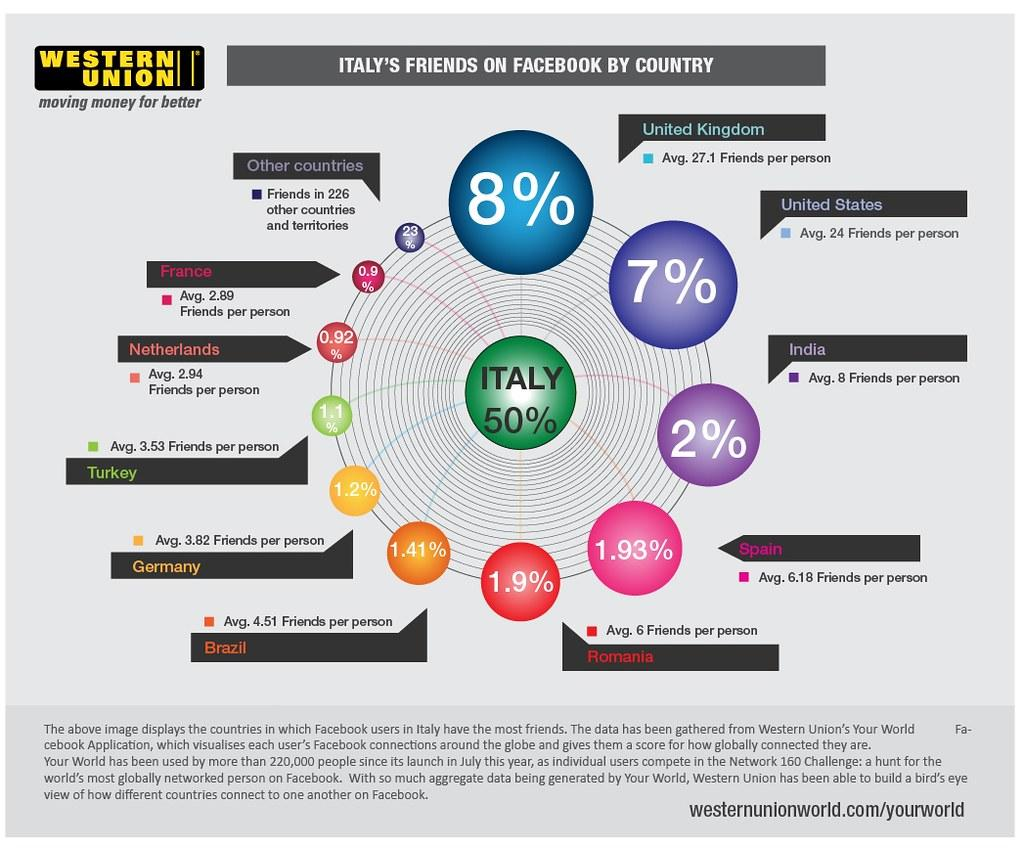Outline some significant characteristics in this image. The country with the lowest percentage of friends from Italy on Facebook is France. According to data, approximately 2% of Facebook friends in Italy are from India. Brazil has the sixth highest percentage of friends from Italy on Facebook. A recent study has revealed that Spain has 1.93% of its Facebook friends in Italy. According to the data on Facebook, Turkey has the eighth highest percentage of friends from Italy among all countries. 